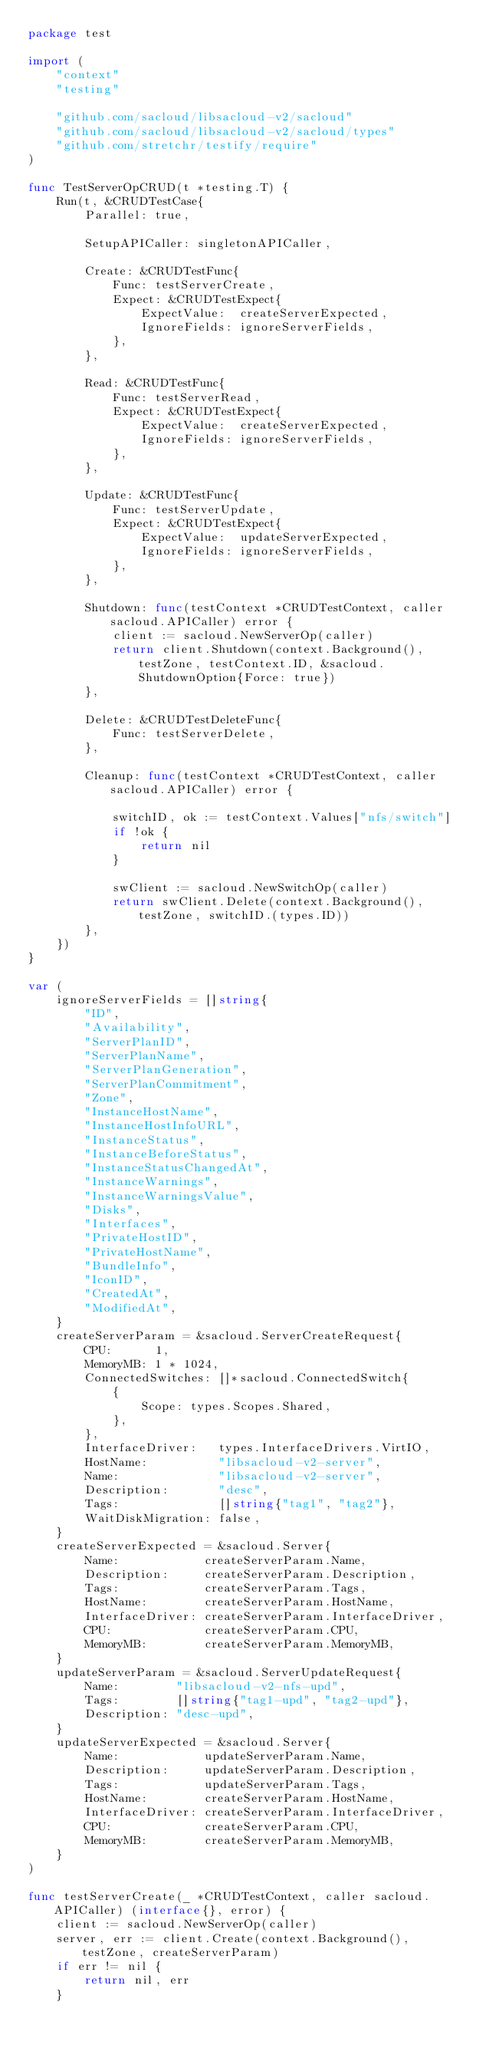<code> <loc_0><loc_0><loc_500><loc_500><_Go_>package test

import (
	"context"
	"testing"

	"github.com/sacloud/libsacloud-v2/sacloud"
	"github.com/sacloud/libsacloud-v2/sacloud/types"
	"github.com/stretchr/testify/require"
)

func TestServerOpCRUD(t *testing.T) {
	Run(t, &CRUDTestCase{
		Parallel: true,

		SetupAPICaller: singletonAPICaller,

		Create: &CRUDTestFunc{
			Func: testServerCreate,
			Expect: &CRUDTestExpect{
				ExpectValue:  createServerExpected,
				IgnoreFields: ignoreServerFields,
			},
		},

		Read: &CRUDTestFunc{
			Func: testServerRead,
			Expect: &CRUDTestExpect{
				ExpectValue:  createServerExpected,
				IgnoreFields: ignoreServerFields,
			},
		},

		Update: &CRUDTestFunc{
			Func: testServerUpdate,
			Expect: &CRUDTestExpect{
				ExpectValue:  updateServerExpected,
				IgnoreFields: ignoreServerFields,
			},
		},

		Shutdown: func(testContext *CRUDTestContext, caller sacloud.APICaller) error {
			client := sacloud.NewServerOp(caller)
			return client.Shutdown(context.Background(), testZone, testContext.ID, &sacloud.ShutdownOption{Force: true})
		},

		Delete: &CRUDTestDeleteFunc{
			Func: testServerDelete,
		},

		Cleanup: func(testContext *CRUDTestContext, caller sacloud.APICaller) error {

			switchID, ok := testContext.Values["nfs/switch"]
			if !ok {
				return nil
			}

			swClient := sacloud.NewSwitchOp(caller)
			return swClient.Delete(context.Background(), testZone, switchID.(types.ID))
		},
	})
}

var (
	ignoreServerFields = []string{
		"ID",
		"Availability",
		"ServerPlanID",
		"ServerPlanName",
		"ServerPlanGeneration",
		"ServerPlanCommitment",
		"Zone",
		"InstanceHostName",
		"InstanceHostInfoURL",
		"InstanceStatus",
		"InstanceBeforeStatus",
		"InstanceStatusChangedAt",
		"InstanceWarnings",
		"InstanceWarningsValue",
		"Disks",
		"Interfaces",
		"PrivateHostID",
		"PrivateHostName",
		"BundleInfo",
		"IconID",
		"CreatedAt",
		"ModifiedAt",
	}
	createServerParam = &sacloud.ServerCreateRequest{
		CPU:      1,
		MemoryMB: 1 * 1024,
		ConnectedSwitches: []*sacloud.ConnectedSwitch{
			{
				Scope: types.Scopes.Shared,
			},
		},
		InterfaceDriver:   types.InterfaceDrivers.VirtIO,
		HostName:          "libsacloud-v2-server",
		Name:              "libsacloud-v2-server",
		Description:       "desc",
		Tags:              []string{"tag1", "tag2"},
		WaitDiskMigration: false,
	}
	createServerExpected = &sacloud.Server{
		Name:            createServerParam.Name,
		Description:     createServerParam.Description,
		Tags:            createServerParam.Tags,
		HostName:        createServerParam.HostName,
		InterfaceDriver: createServerParam.InterfaceDriver,
		CPU:             createServerParam.CPU,
		MemoryMB:        createServerParam.MemoryMB,
	}
	updateServerParam = &sacloud.ServerUpdateRequest{
		Name:        "libsacloud-v2-nfs-upd",
		Tags:        []string{"tag1-upd", "tag2-upd"},
		Description: "desc-upd",
	}
	updateServerExpected = &sacloud.Server{
		Name:            updateServerParam.Name,
		Description:     updateServerParam.Description,
		Tags:            updateServerParam.Tags,
		HostName:        createServerParam.HostName,
		InterfaceDriver: createServerParam.InterfaceDriver,
		CPU:             createServerParam.CPU,
		MemoryMB:        createServerParam.MemoryMB,
	}
)

func testServerCreate(_ *CRUDTestContext, caller sacloud.APICaller) (interface{}, error) {
	client := sacloud.NewServerOp(caller)
	server, err := client.Create(context.Background(), testZone, createServerParam)
	if err != nil {
		return nil, err
	}</code> 